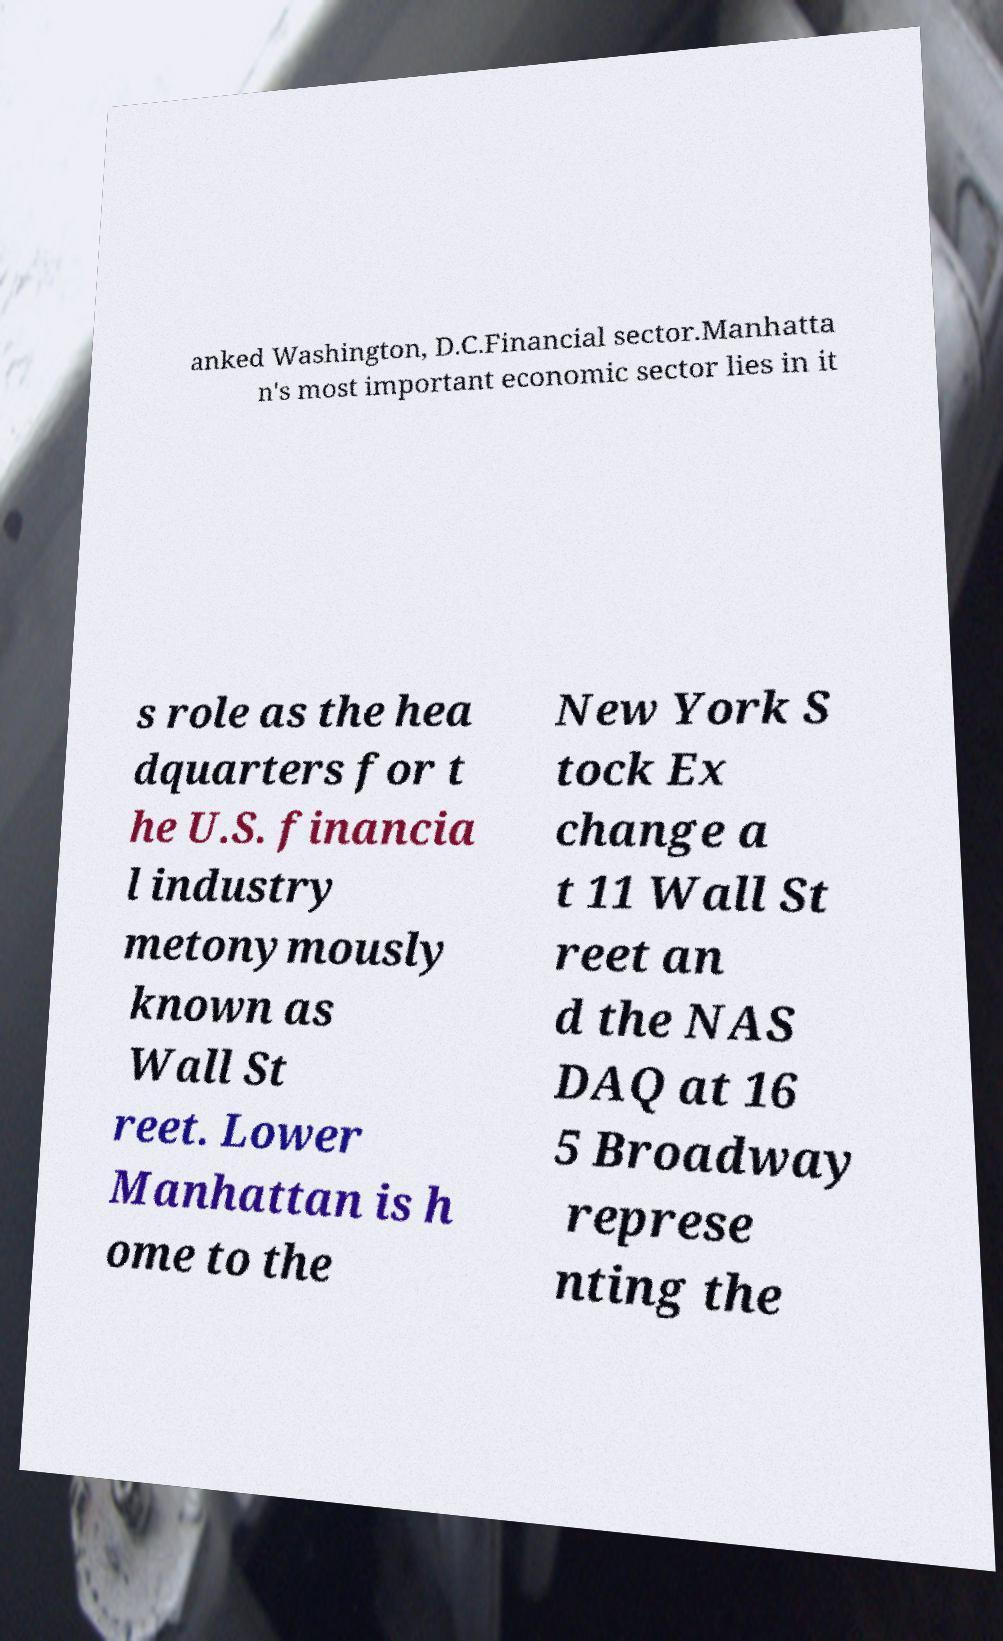What messages or text are displayed in this image? I need them in a readable, typed format. anked Washington, D.C.Financial sector.Manhatta n's most important economic sector lies in it s role as the hea dquarters for t he U.S. financia l industry metonymously known as Wall St reet. Lower Manhattan is h ome to the New York S tock Ex change a t 11 Wall St reet an d the NAS DAQ at 16 5 Broadway represe nting the 